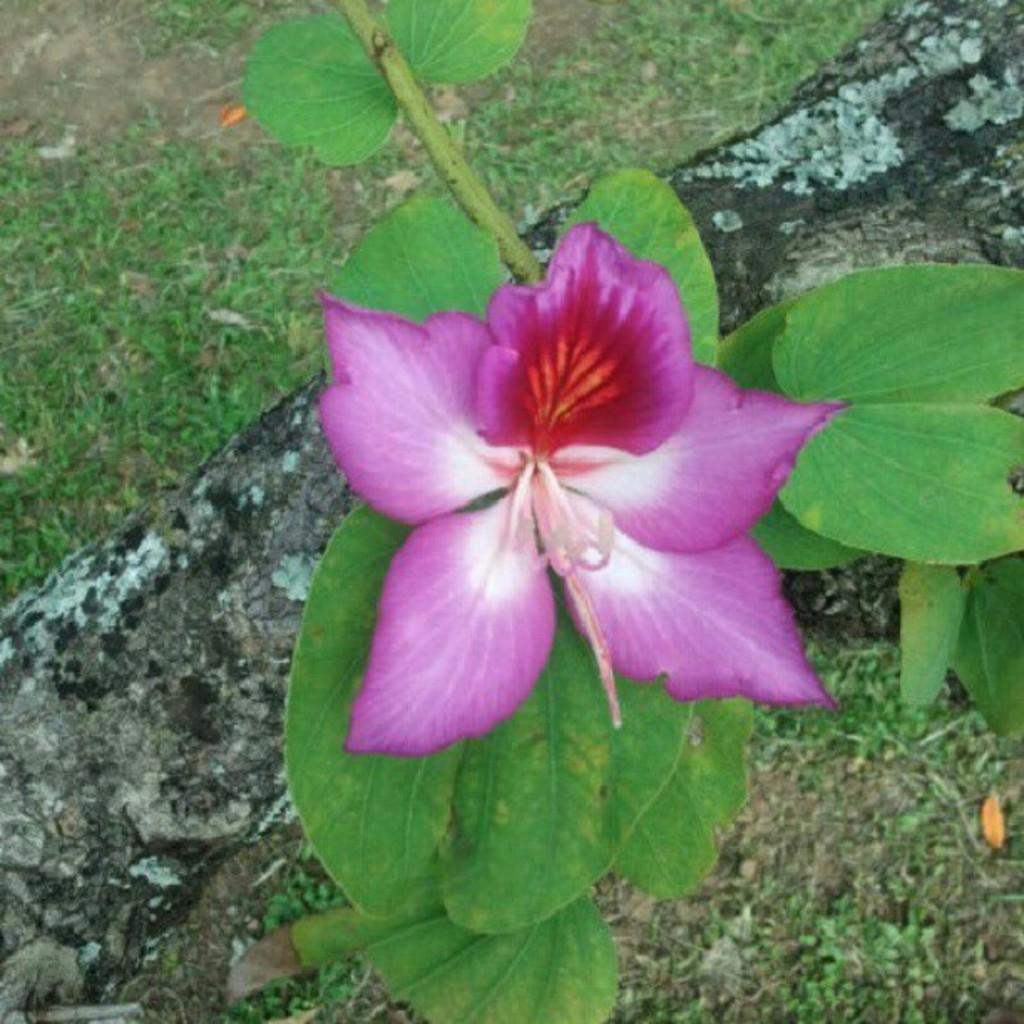What type of plant life is present in the image? There is a flower on a plant in the image. Can you describe the color of the flower? The flower is purple in color. What other natural elements can be seen in the image? There is a log and grass visible in the image. What type of linen is draped over the flower in the image? There is no linen present in the image; the flower is on a plant and not draped with any fabric. 